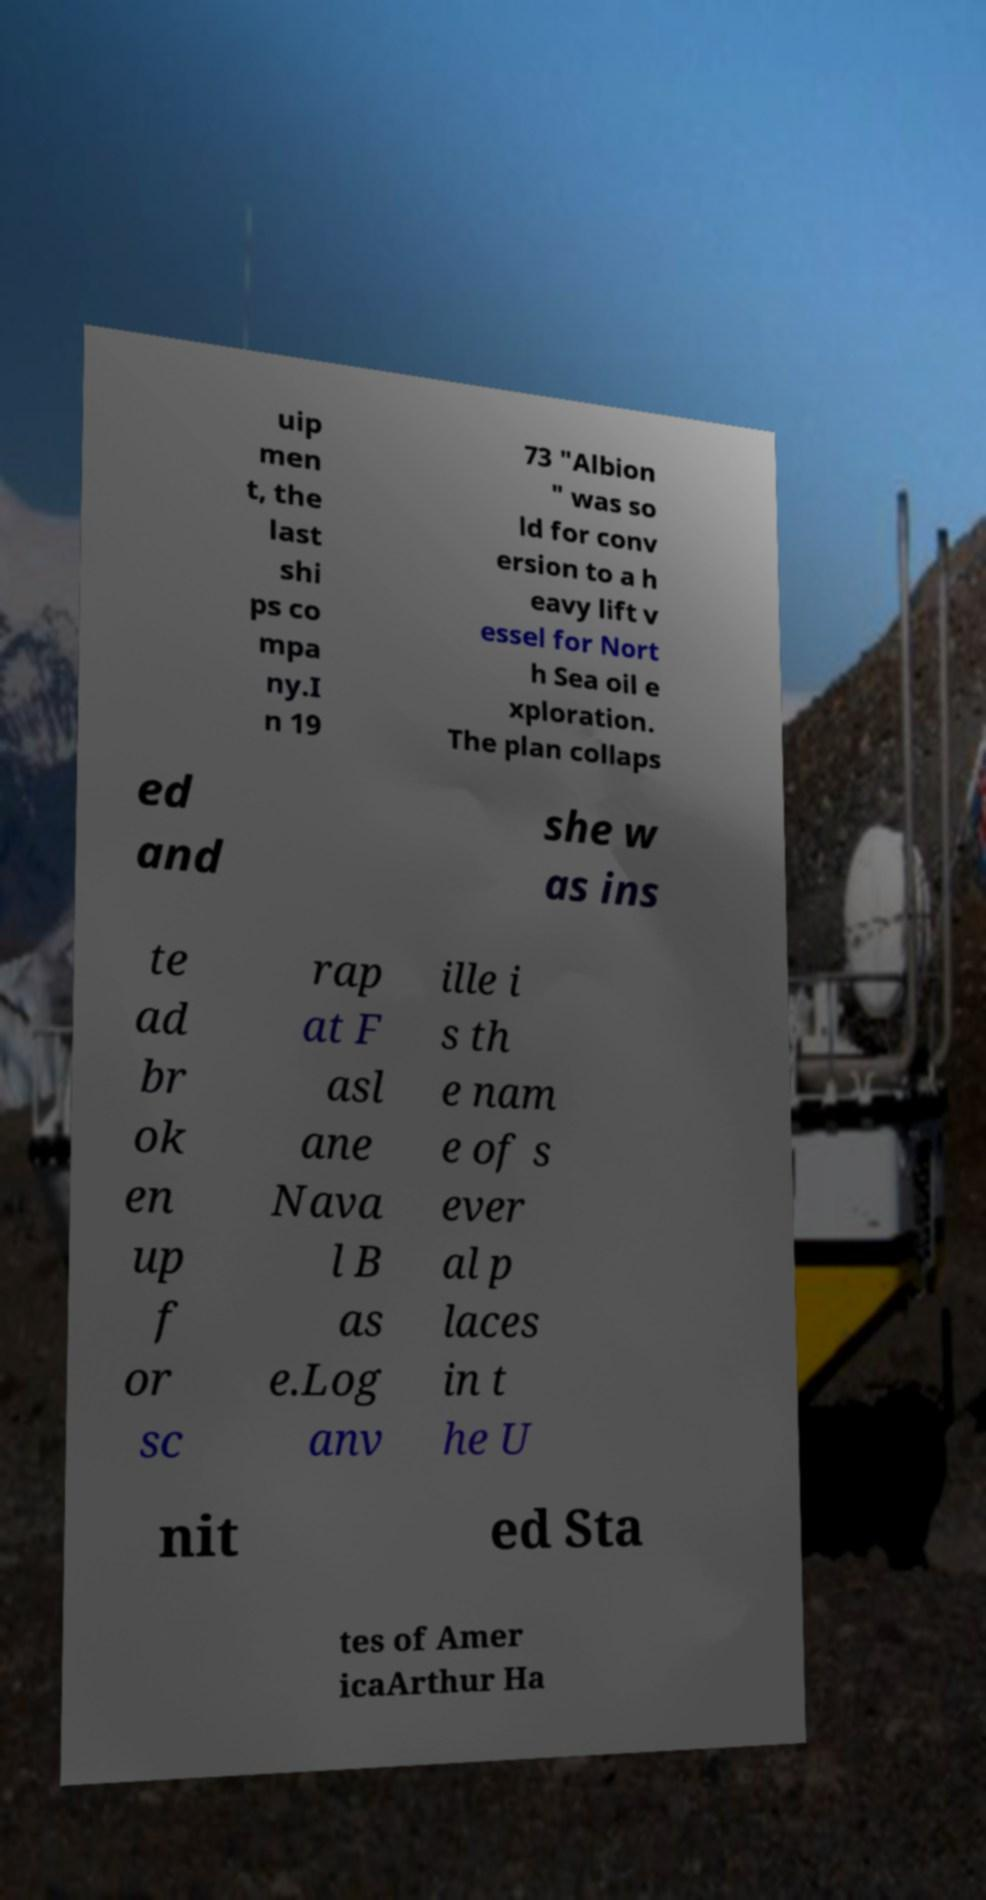Please identify and transcribe the text found in this image. uip men t, the last shi ps co mpa ny.I n 19 73 "Albion " was so ld for conv ersion to a h eavy lift v essel for Nort h Sea oil e xploration. The plan collaps ed and she w as ins te ad br ok en up f or sc rap at F asl ane Nava l B as e.Log anv ille i s th e nam e of s ever al p laces in t he U nit ed Sta tes of Amer icaArthur Ha 